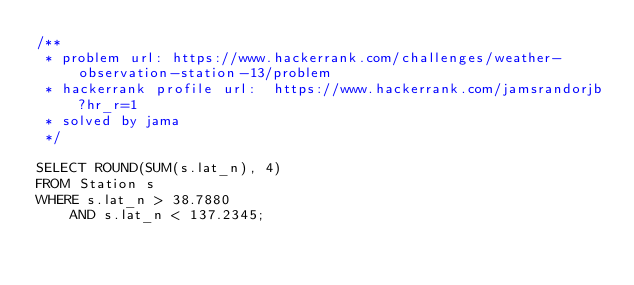<code> <loc_0><loc_0><loc_500><loc_500><_SQL_>/**
 * problem url: https://www.hackerrank.com/challenges/weather-observation-station-13/problem
 * hackerrank profile url:  https://www.hackerrank.com/jamsrandorjb?hr_r=1
 * solved by jama
 */

SELECT ROUND(SUM(s.lat_n), 4)
FROM Station s
WHERE s.lat_n > 38.7880 
    AND s.lat_n < 137.2345;
</code> 